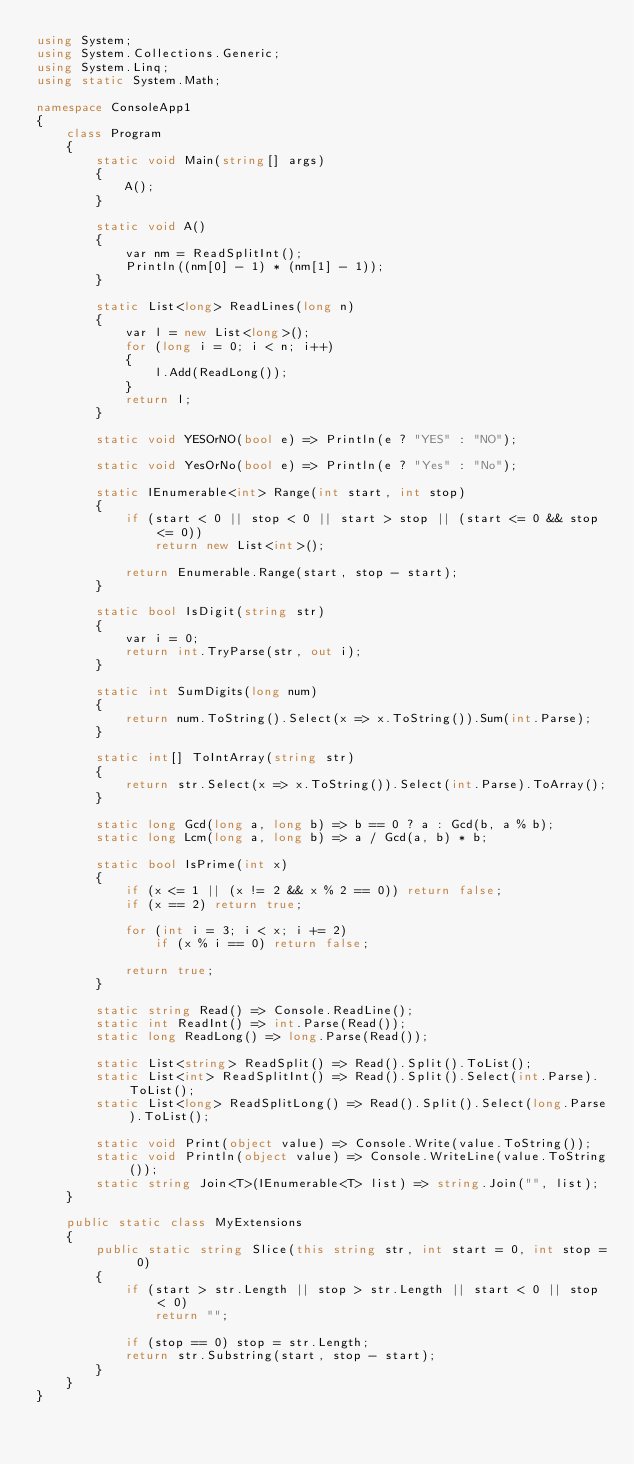Convert code to text. <code><loc_0><loc_0><loc_500><loc_500><_C#_>using System;
using System.Collections.Generic;
using System.Linq;
using static System.Math;

namespace ConsoleApp1
{
    class Program
    {
        static void Main(string[] args)
        {
            A();
        }

        static void A()
        {
            var nm = ReadSplitInt();
            Println((nm[0] - 1) * (nm[1] - 1));
        }

        static List<long> ReadLines(long n)
        {
            var l = new List<long>();
            for (long i = 0; i < n; i++)
            {
                l.Add(ReadLong());
            }
            return l;
        }

        static void YESOrNO(bool e) => Println(e ? "YES" : "NO");

        static void YesOrNo(bool e) => Println(e ? "Yes" : "No");

        static IEnumerable<int> Range(int start, int stop)
        {
            if (start < 0 || stop < 0 || start > stop || (start <= 0 && stop <= 0))
                return new List<int>();

            return Enumerable.Range(start, stop - start);
        }

        static bool IsDigit(string str)
        {
            var i = 0;
            return int.TryParse(str, out i);
        }

        static int SumDigits(long num)
        {
            return num.ToString().Select(x => x.ToString()).Sum(int.Parse);
        }

        static int[] ToIntArray(string str)
        {
            return str.Select(x => x.ToString()).Select(int.Parse).ToArray();
        }

        static long Gcd(long a, long b) => b == 0 ? a : Gcd(b, a % b);
        static long Lcm(long a, long b) => a / Gcd(a, b) * b;

        static bool IsPrime(int x)
        {
            if (x <= 1 || (x != 2 && x % 2 == 0)) return false;
            if (x == 2) return true;

            for (int i = 3; i < x; i += 2)
                if (x % i == 0) return false;

            return true;
        }

        static string Read() => Console.ReadLine();
        static int ReadInt() => int.Parse(Read());
        static long ReadLong() => long.Parse(Read());

        static List<string> ReadSplit() => Read().Split().ToList();
        static List<int> ReadSplitInt() => Read().Split().Select(int.Parse).ToList();
        static List<long> ReadSplitLong() => Read().Split().Select(long.Parse).ToList();

        static void Print(object value) => Console.Write(value.ToString());
        static void Println(object value) => Console.WriteLine(value.ToString());
        static string Join<T>(IEnumerable<T> list) => string.Join("", list);
    }

    public static class MyExtensions
    {
        public static string Slice(this string str, int start = 0, int stop = 0)
        {
            if (start > str.Length || stop > str.Length || start < 0 || stop < 0)
                return "";

            if (stop == 0) stop = str.Length;
            return str.Substring(start, stop - start);
        }
    }
}

</code> 